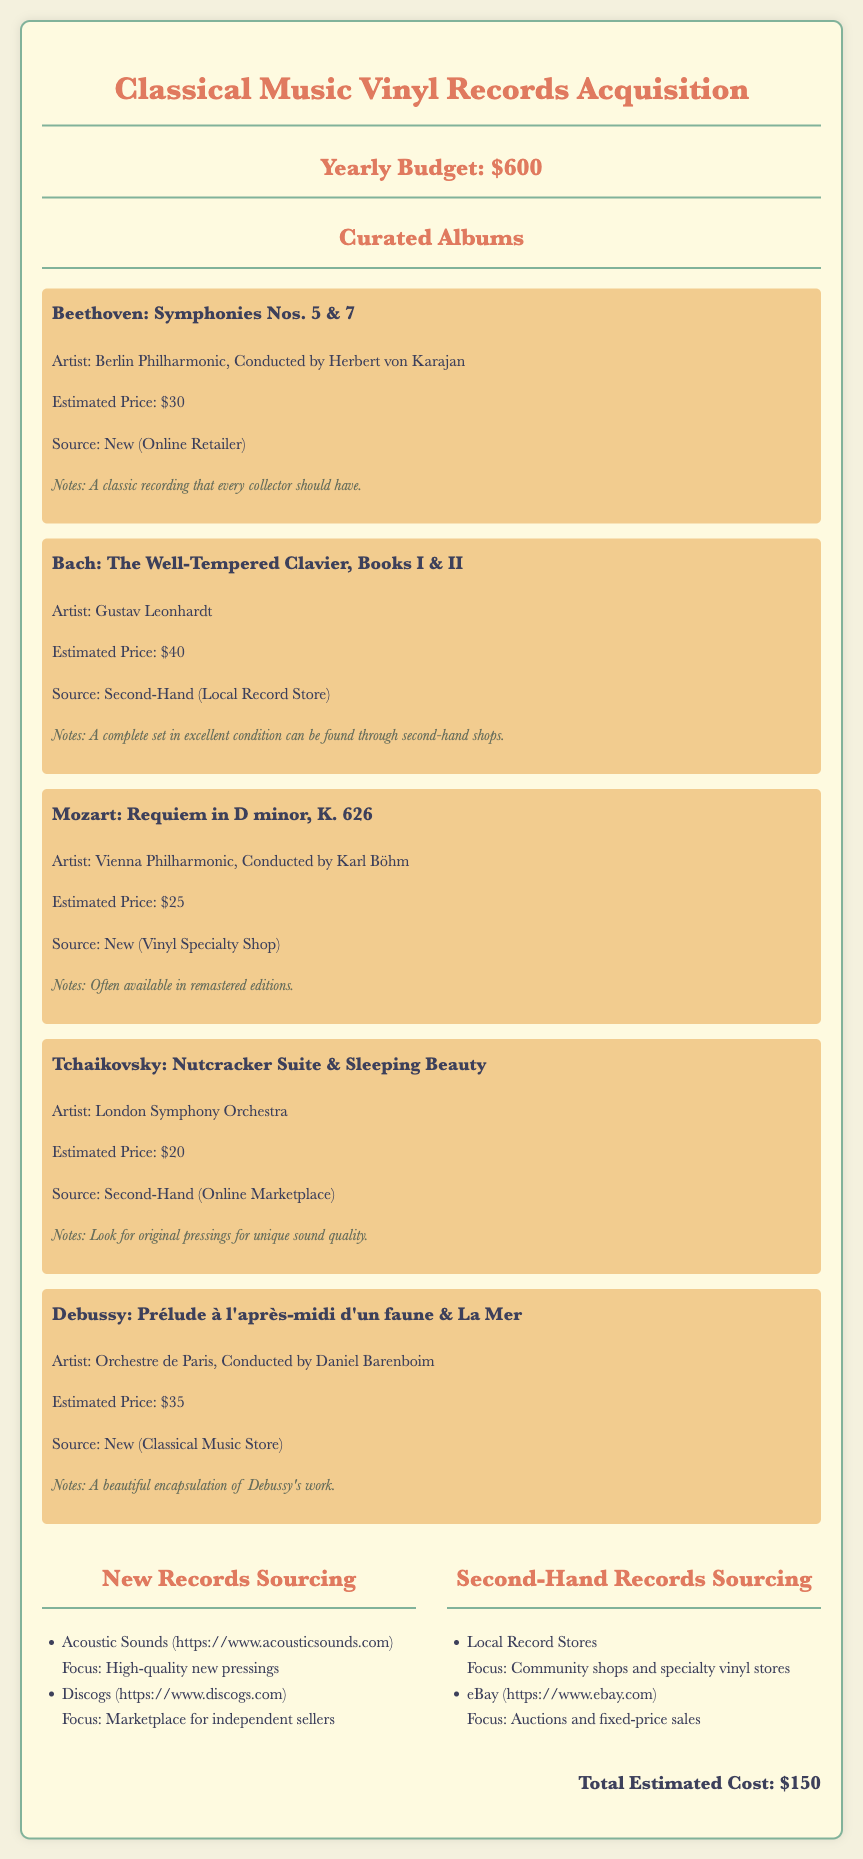What is the yearly budget for vinyl records acquisition? The yearly budget stated in the document is specifically mentioned as $600.
Answer: $600 How many albums are listed in the curated selection? The document outlines a total of five specific albums in the curated selection.
Answer: 5 What is the estimated price of Bach's The Well-Tempered Clavier? The document indicates that the estimated price for Bach's The Well-Tempered Clavier is $40.
Answer: $40 Which artist conducted Tchaikovsky's Nutcracker Suite & Sleeping Beauty? The document lists the London Symphony Orchestra as the performer, but does not specify the conductor.
Answer: London Symphony Orchestra What is the source for Beethoven's Symphonies Nos. 5 & 7? The document specifies that the source for Beethoven's Symphonies Nos. 5 & 7 is New (Online Retailer).
Answer: New (Online Retailer) What is the total estimated cost of the albums? The total estimated cost for all listed albums comes to $150, as noted in the document.
Answer: $150 Which platform is mentioned for finding second-hand records? The document lists eBay as one of the platforms for sourcing second-hand records.
Answer: eBay What is the focus of Acoustic Sounds as per the document? The document states that Acoustic Sounds focuses on high-quality new pressings.
Answer: High-quality new pressings Who is the artist for Debussy's Prélude à l'après-midi d'un faune & La Mer? The document credits Orchestre de Paris, Conducted by Daniel Barenboim as the artist for Debussy's work.
Answer: Orchestre de Paris, Conducted by Daniel Barenboim 